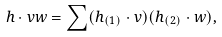<formula> <loc_0><loc_0><loc_500><loc_500>h \cdot v w = \sum ( h _ { ( 1 ) } \cdot v ) ( h _ { ( 2 ) } \cdot w ) ,</formula> 